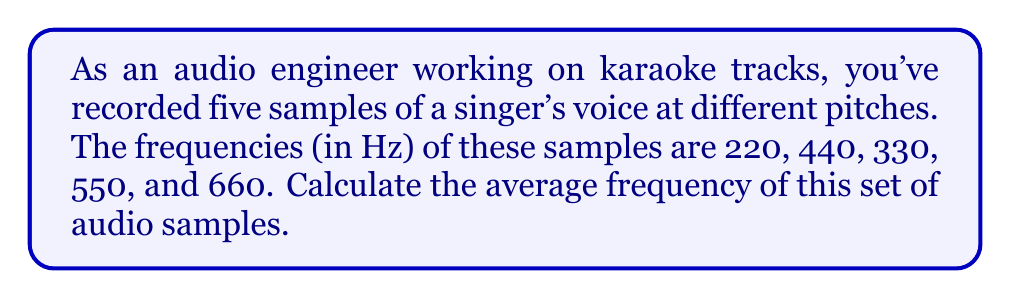Could you help me with this problem? To calculate the average frequency of a set of audio samples, we need to use the arithmetic mean formula. The arithmetic mean is calculated by summing all the values in a dataset and dividing by the number of values.

Let's follow these steps:

1. Identify the given frequencies:
   $f_1 = 220$ Hz
   $f_2 = 440$ Hz
   $f_3 = 330$ Hz
   $f_4 = 550$ Hz
   $f_5 = 660$ Hz

2. Count the number of samples:
   $n = 5$

3. Calculate the sum of all frequencies:
   $$\sum_{i=1}^n f_i = 220 + 440 + 330 + 550 + 660 = 2200 \text{ Hz}$$

4. Apply the arithmetic mean formula:
   $$\bar{f} = \frac{\sum_{i=1}^n f_i}{n}$$

   Where:
   $\bar{f}$ is the average frequency
   $\sum_{i=1}^n f_i$ is the sum of all frequencies
   $n$ is the number of samples

5. Substitute the values and calculate:
   $$\bar{f} = \frac{2200}{5} = 440 \text{ Hz}$$

Therefore, the average frequency of the set of audio samples is 440 Hz.
Answer: $440 \text{ Hz}$ 